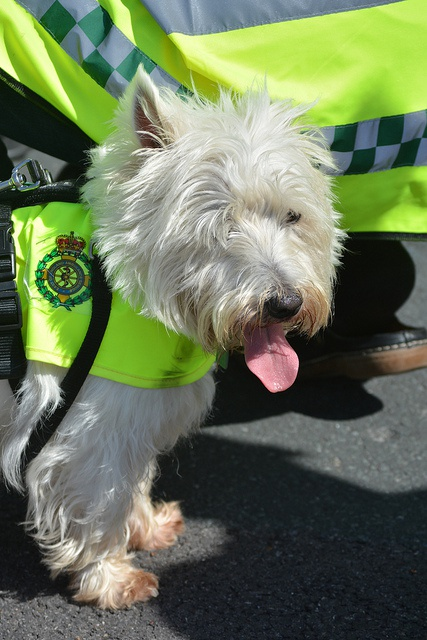Describe the objects in this image and their specific colors. I can see a dog in khaki, darkgray, gray, lightgray, and olive tones in this image. 